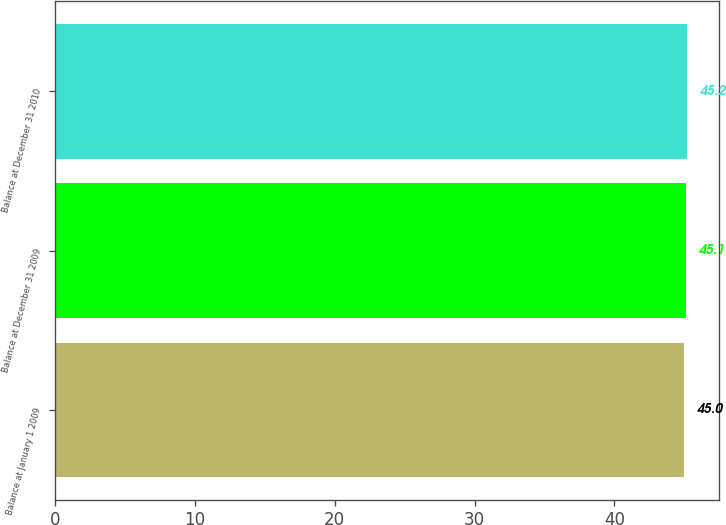Convert chart. <chart><loc_0><loc_0><loc_500><loc_500><bar_chart><fcel>Balance at January 1 2009<fcel>Balance at December 31 2009<fcel>Balance at December 31 2010<nl><fcel>45<fcel>45.1<fcel>45.2<nl></chart> 